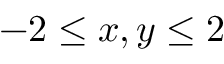Convert formula to latex. <formula><loc_0><loc_0><loc_500><loc_500>- 2 \leq x , y \leq 2</formula> 